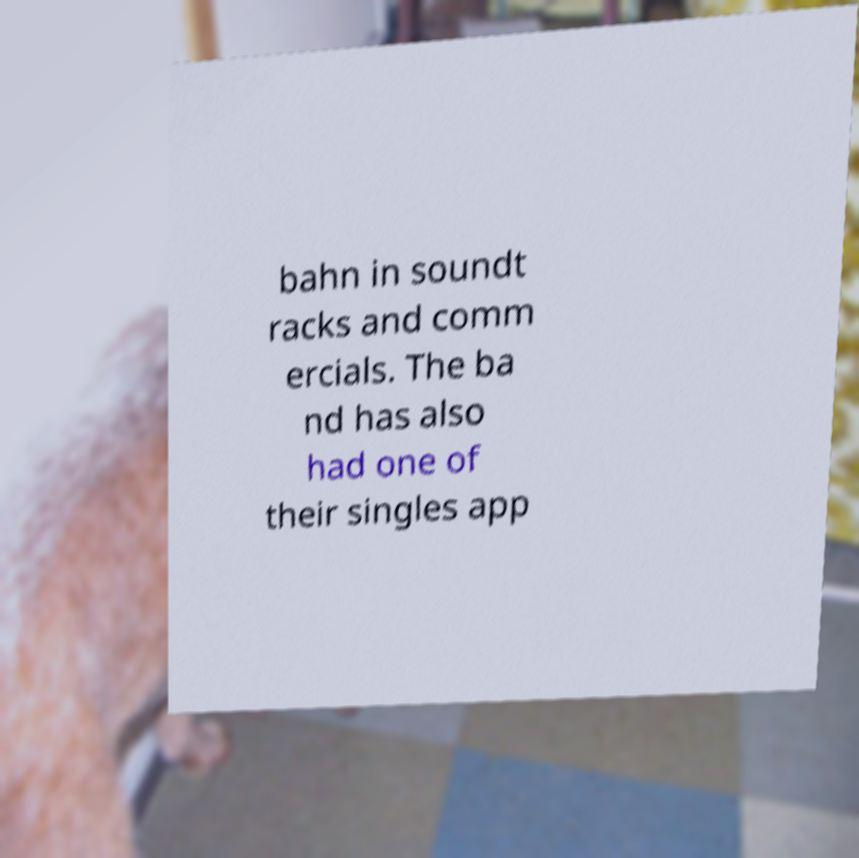For documentation purposes, I need the text within this image transcribed. Could you provide that? bahn in soundt racks and comm ercials. The ba nd has also had one of their singles app 